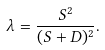<formula> <loc_0><loc_0><loc_500><loc_500>\lambda = \frac { S ^ { 2 } } { ( S + D ) ^ { 2 } } .</formula> 